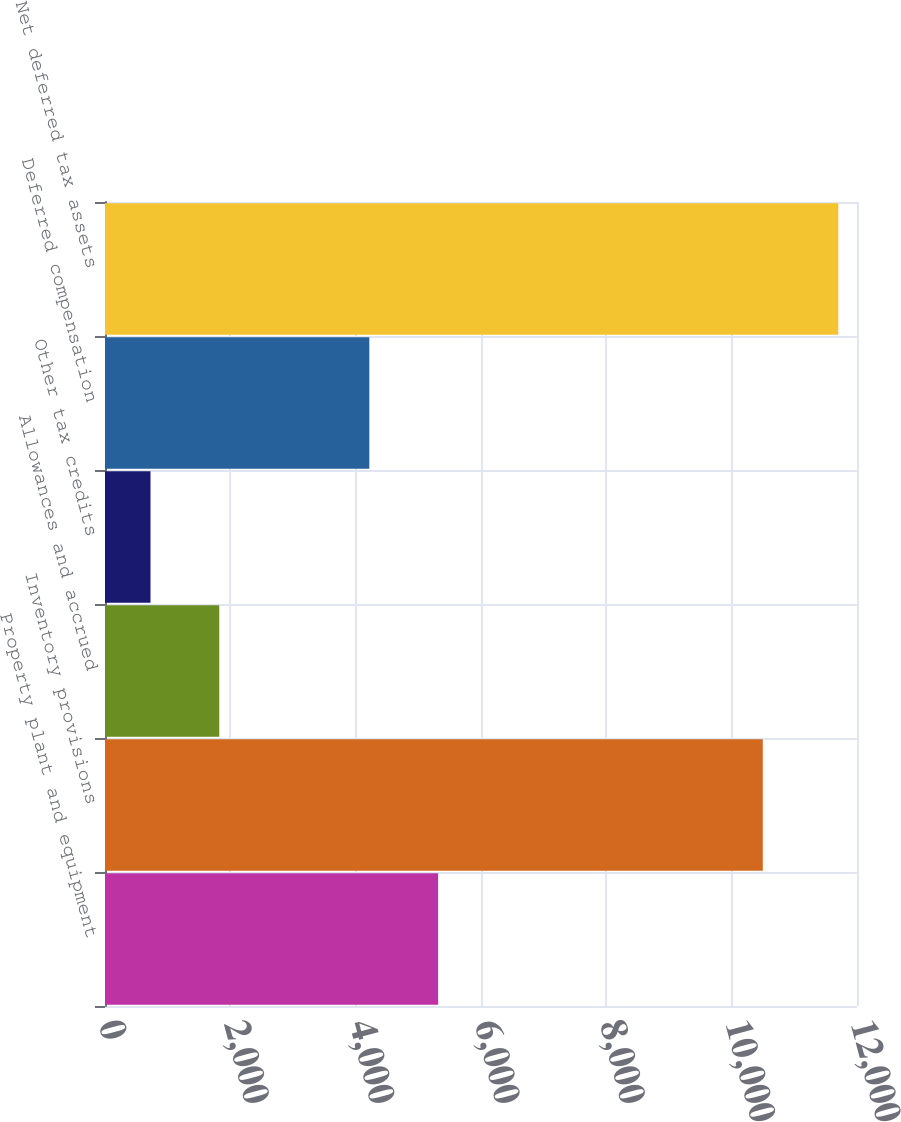<chart> <loc_0><loc_0><loc_500><loc_500><bar_chart><fcel>Property plant and equipment<fcel>Inventory provisions<fcel>Allowances and accrued<fcel>Other tax credits<fcel>Deferred compensation<fcel>Net deferred tax assets<nl><fcel>5315.5<fcel>10497<fcel>1823.5<fcel>726<fcel>4218<fcel>11701<nl></chart> 